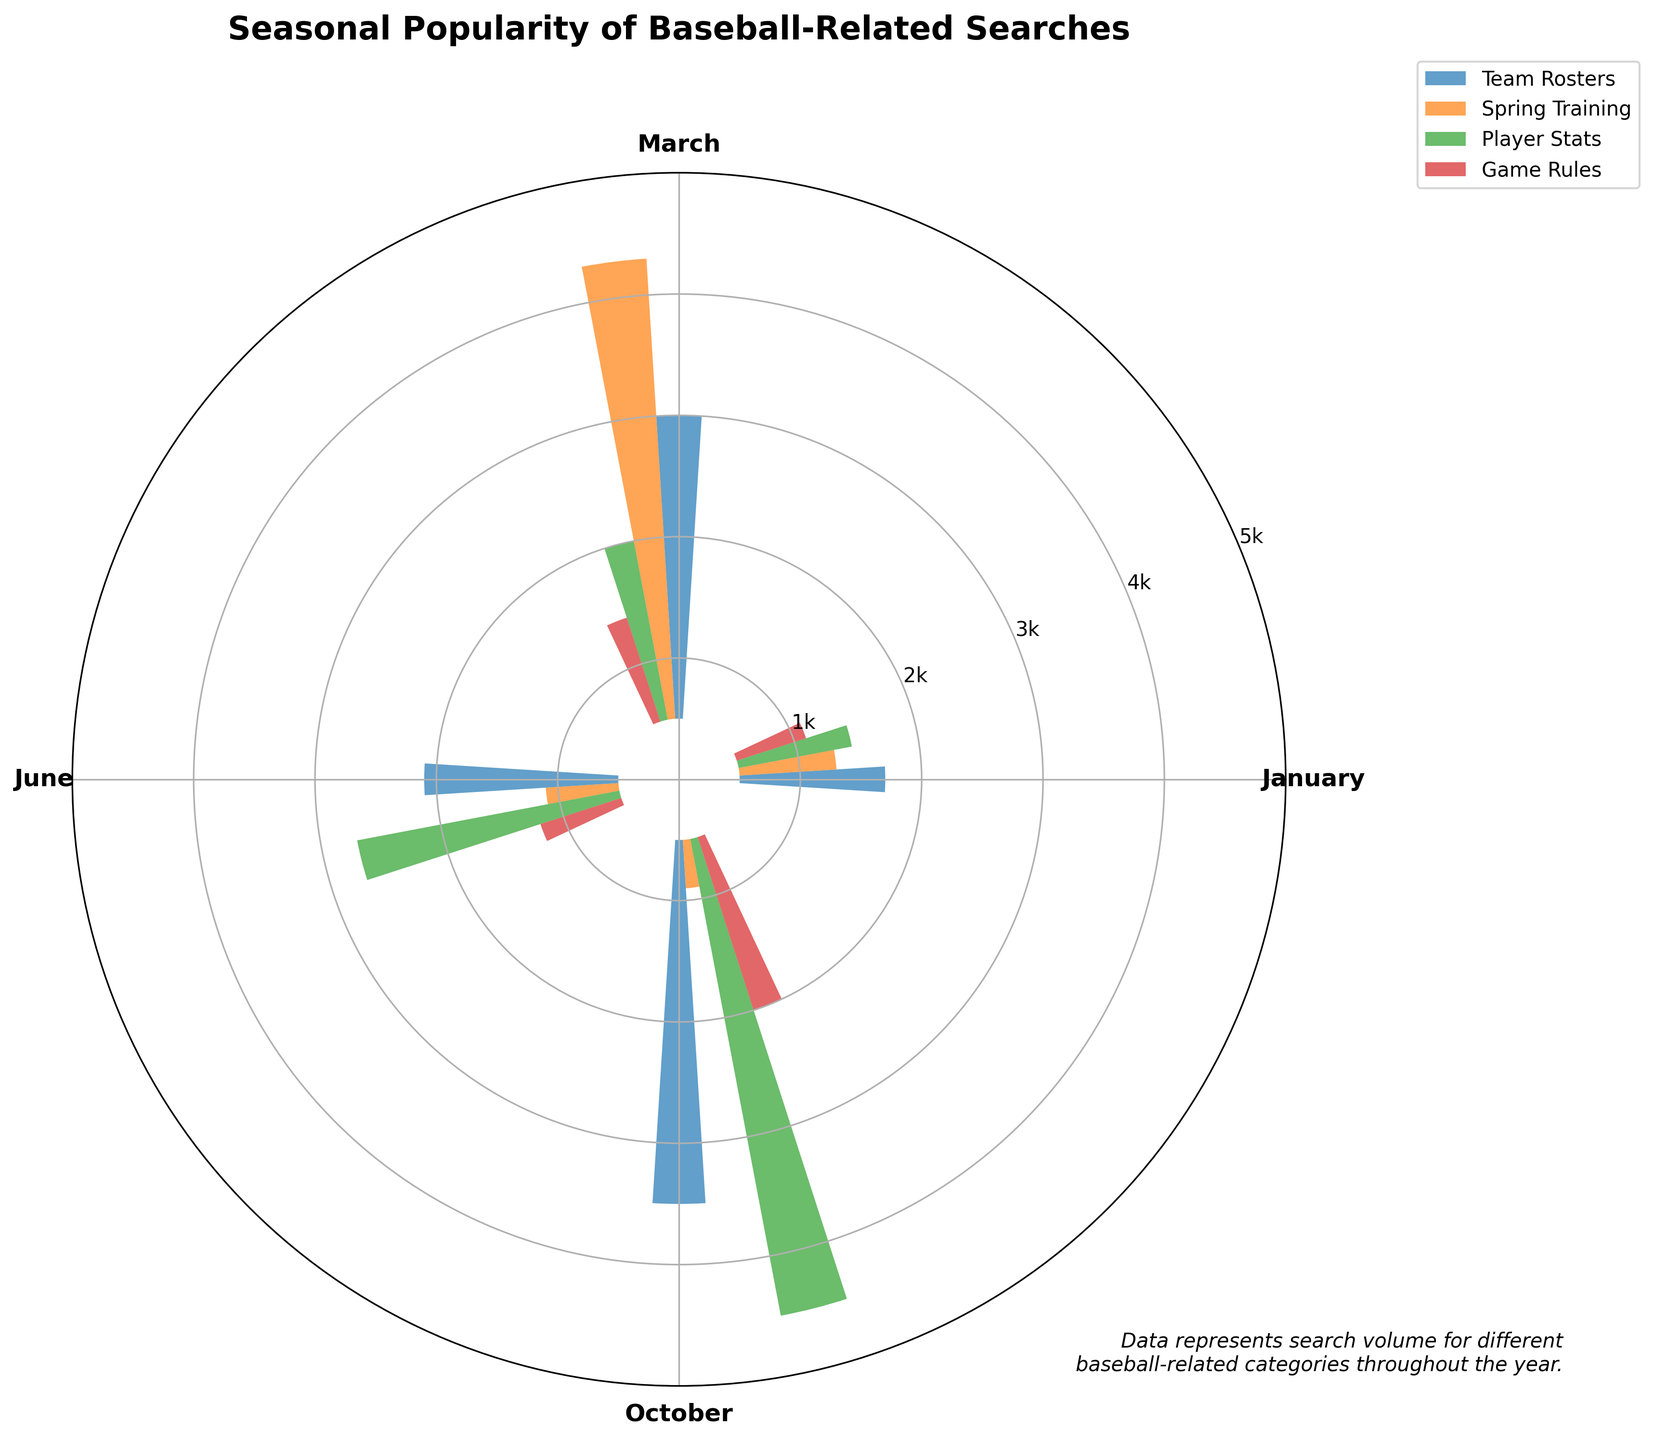What's the title of the chart? The title is located at the top of the chart and can be read directly.
Answer: Seasonal Popularity of Baseball-Related Searches Which month has the highest search volume for 'Player Stats'? By looking towards where 'Player Stats' bars are plotted, you can see the highest bar for this category occurs in the month of October.
Answer: October What is the total search volume for 'Spring Training' across all months? Add 'Spring Training' volumes for each month: 800 (Jan) + 3800 (March) + 600 (June) + 400 (Oct) = 5600.
Answer: 5600 In which month is the search volume for 'Game Rules' the lowest? Compare the height of all 'Game Rules' bars; the lowest one is in January.
Answer: January Which category has the highest search volume in March? By comparing the heights of the bars for March, 'Spring Training' has the highest value.
Answer: Spring Training What is the average search volume for 'Team Rosters' over the four months? Sum the values: 1200 (Jan) + 2500 (March) + 1600 (June) + 3000 (Oct) = 8300. The average is 8300 / 4 = 2075.
Answer: 2075 Compare the search volumes for 'Player Stats' in January and June. Which one is higher? Look at the heights of the 'Player Stats' bars in January (950) and June (2200); June is higher.
Answer: June What is the difference in search volume for 'Spring Training' between March and June? The search volume in March is 3800 and in June is 600. The difference is 3800 - 600 = 3200.
Answer: 3200 Which month has the overall highest search volume across all categories combined? Add all categories for each month: January: 1200 + 800 + 950 + 600 = 3550, March: 2500 + 3800 + 1500 + 900 = 8700, June: 1600 + 600 + 2200 + 700 = 5100, October: 3000 + 400 + 4000 + 1500 = 8900. October is highest.
Answer: October What is the general trend in the search volume for 'Team Rosters'? Observing the heights of 'Team Rosters' bars across the months will show an increasing trend from January to October.
Answer: Increasing 